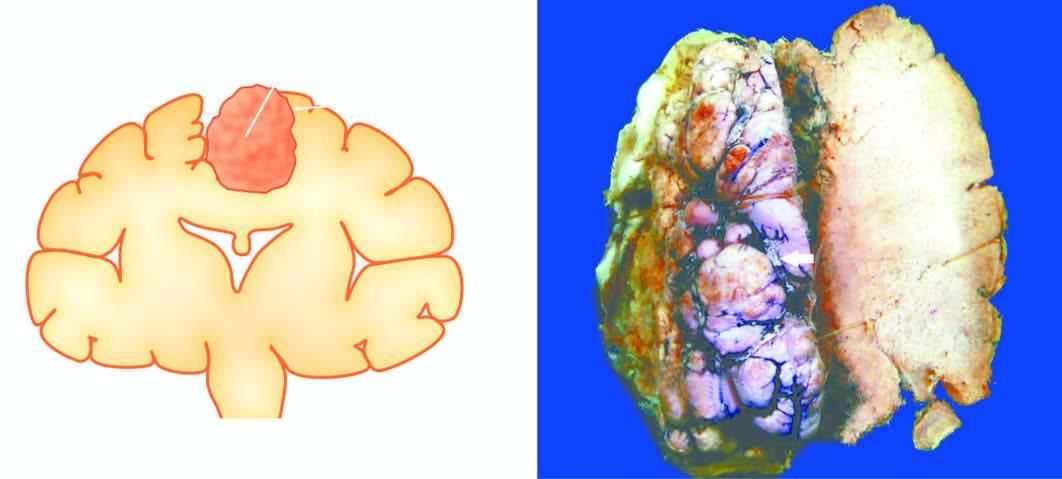what is circumscribed with irregular surface convolutions and prominent blood vessels?
Answer the question using a single word or phrase. Tumour mass 